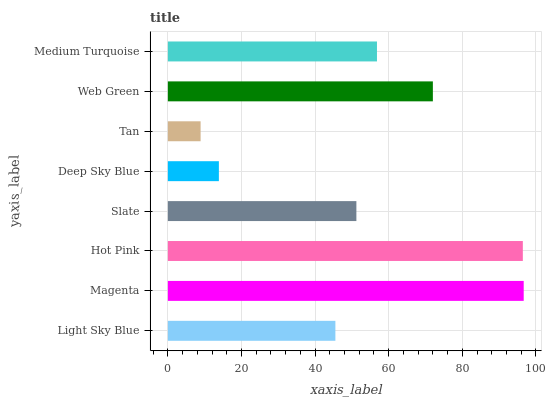Is Tan the minimum?
Answer yes or no. Yes. Is Magenta the maximum?
Answer yes or no. Yes. Is Hot Pink the minimum?
Answer yes or no. No. Is Hot Pink the maximum?
Answer yes or no. No. Is Magenta greater than Hot Pink?
Answer yes or no. Yes. Is Hot Pink less than Magenta?
Answer yes or no. Yes. Is Hot Pink greater than Magenta?
Answer yes or no. No. Is Magenta less than Hot Pink?
Answer yes or no. No. Is Medium Turquoise the high median?
Answer yes or no. Yes. Is Slate the low median?
Answer yes or no. Yes. Is Slate the high median?
Answer yes or no. No. Is Light Sky Blue the low median?
Answer yes or no. No. 